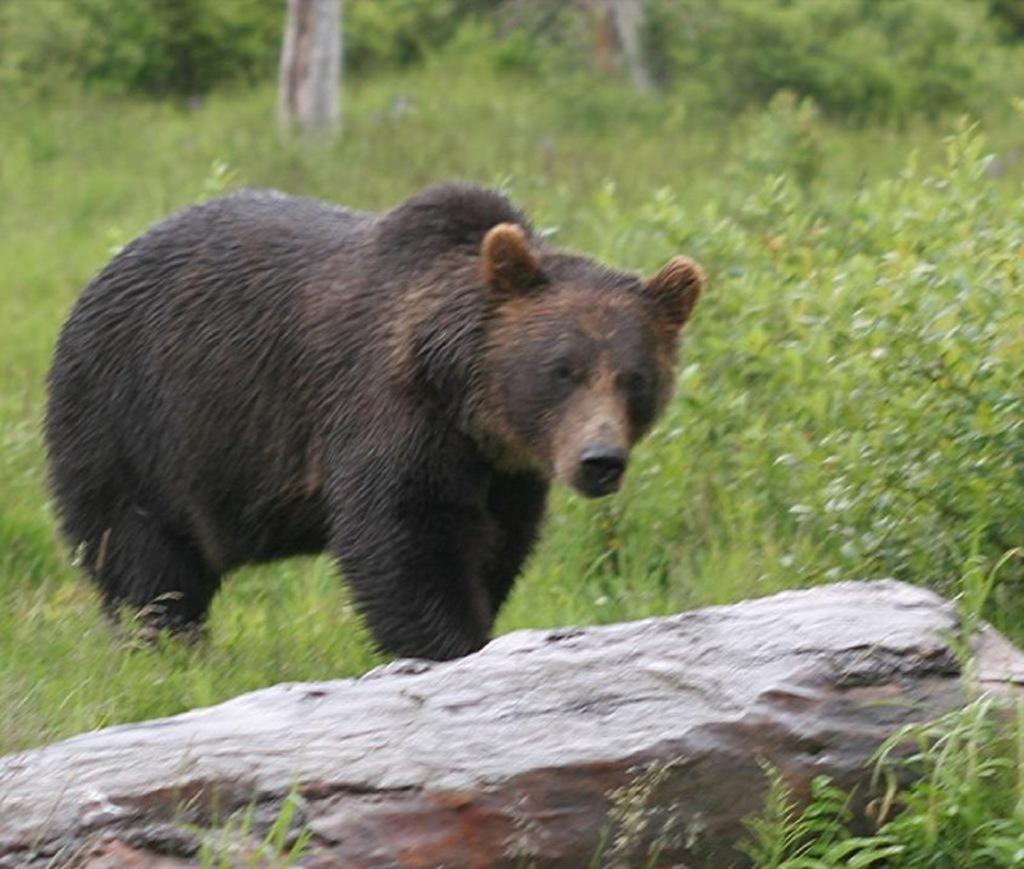What type of animal is in the image? There is a brown bear in the image. What can be seen at the bottom of the image? There are stones at the bottom of the image. What type of vegetation is visible in the image? There are trees visible at the back side of the image. What type of mark does the owl leave on the stones in the image? There is no owl present in the image, so it is not possible to determine what type of mark it might leave on the stones. 